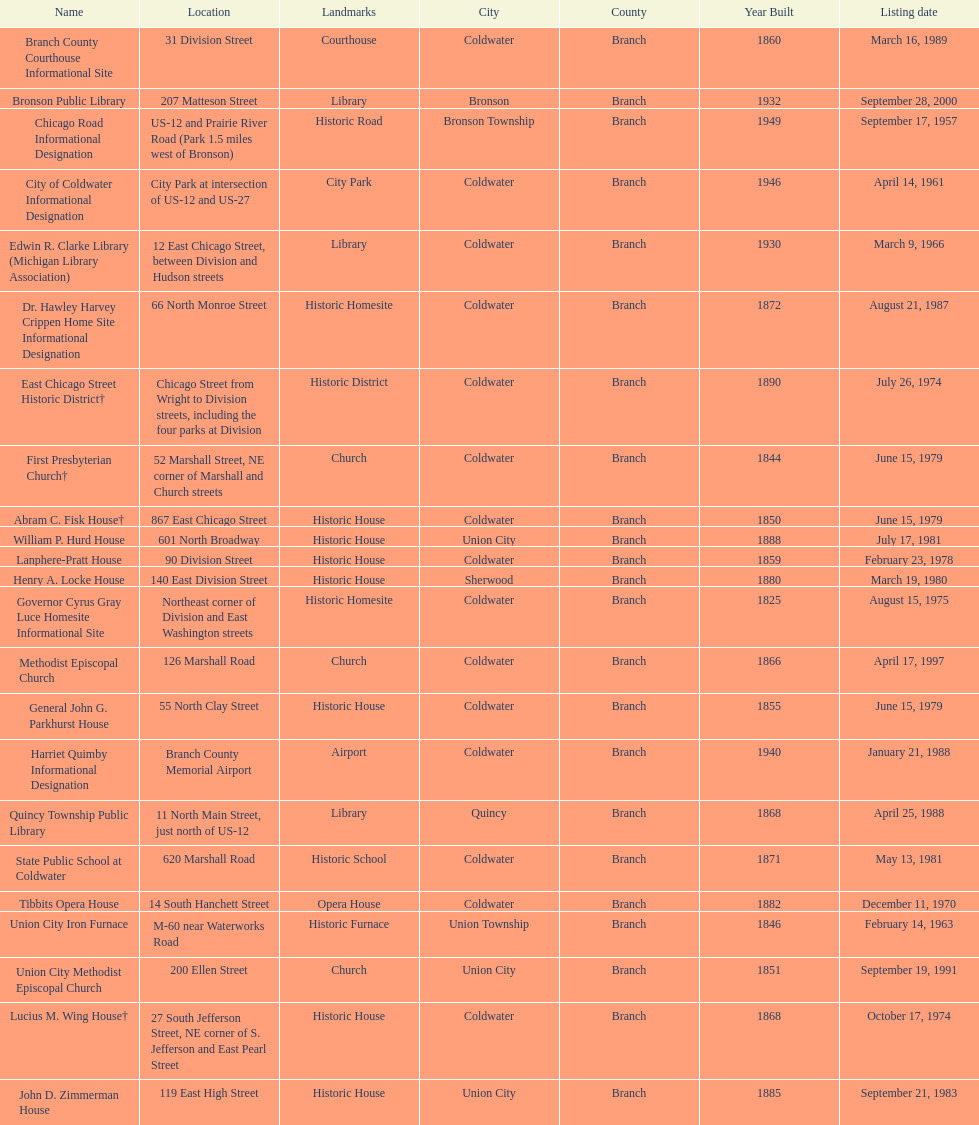How many sites were listed as historical before 1980? 12. 